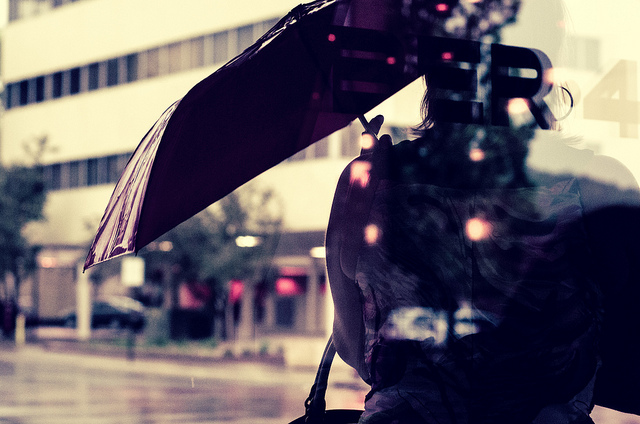<image>Is it raining outside? I don't know if it's raining outside. Is it raining outside? I don't know if it is raining outside. It seems like it is raining. 